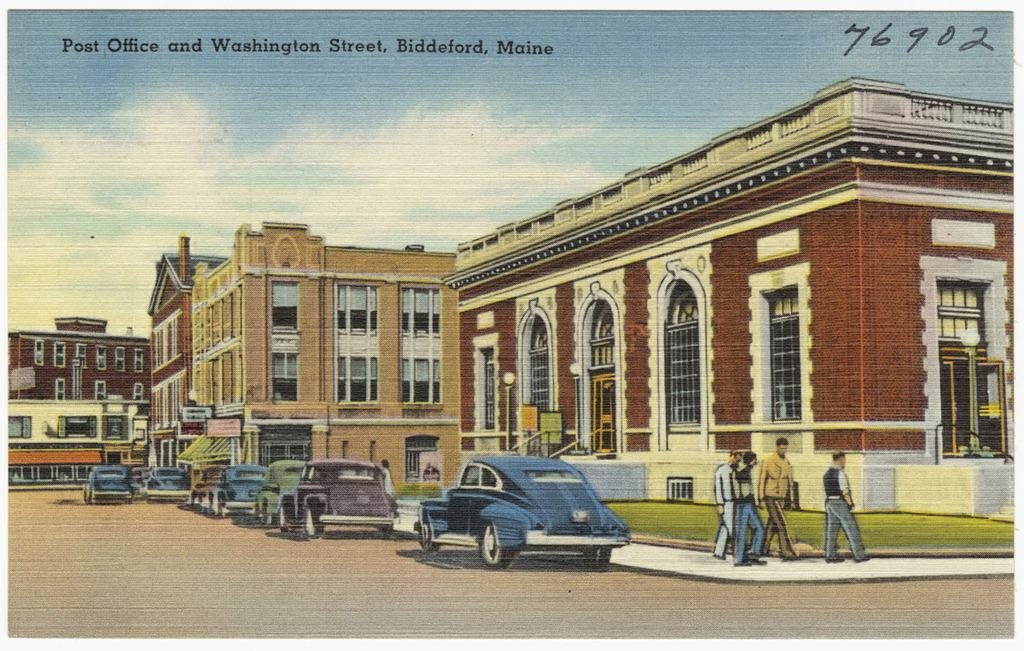What type of artwork is depicted in the image? The image is a drawing. What structures are included in the drawing? There are buildings in the drawing. What mode of transportation is present in the drawing? There are cars in the drawing. What activity are the people in the drawing engaged in? There are people walking in the drawing. What type of pathway is shown in the drawing? There is a road in the drawing. What is written at the top of the image? There is some text at the top of the image. What type of iron is being used by the people in the drawing? There is no iron present in the drawing; people are walking instead. How much payment is required to use the road in the drawing? There is no indication of payment required to use the road in the drawing. 